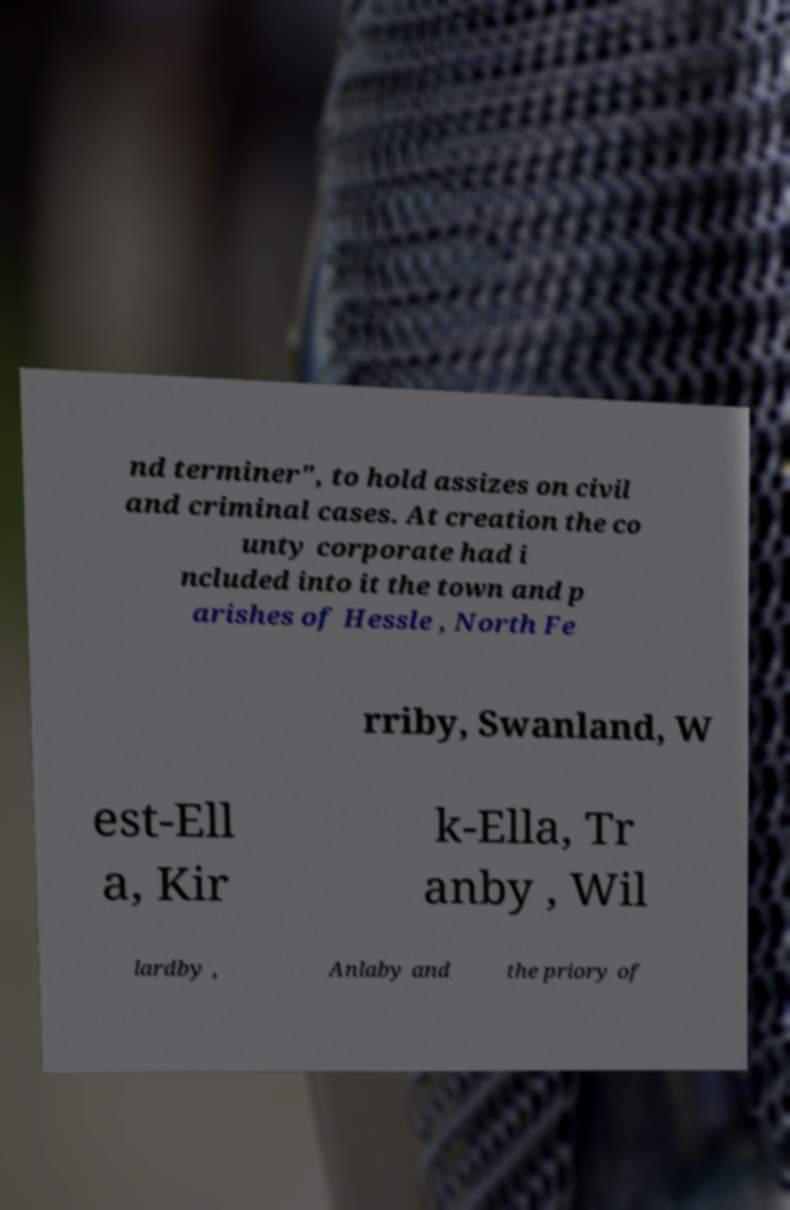What messages or text are displayed in this image? I need them in a readable, typed format. nd terminer", to hold assizes on civil and criminal cases. At creation the co unty corporate had i ncluded into it the town and p arishes of Hessle , North Fe rriby, Swanland, W est-Ell a, Kir k-Ella, Tr anby , Wil lardby , Anlaby and the priory of 